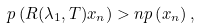Convert formula to latex. <formula><loc_0><loc_0><loc_500><loc_500>p \left ( R ( \lambda _ { 1 } , T ) x _ { n } \right ) > n p \left ( x _ { n } \right ) ,</formula> 